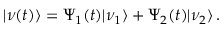Convert formula to latex. <formula><loc_0><loc_0><loc_500><loc_500>| \nu ( t ) \rangle = \Psi _ { 1 } ( t ) | \nu _ { 1 } \rangle + \Psi _ { 2 } ( t ) | \nu _ { 2 } \rangle \, .</formula> 